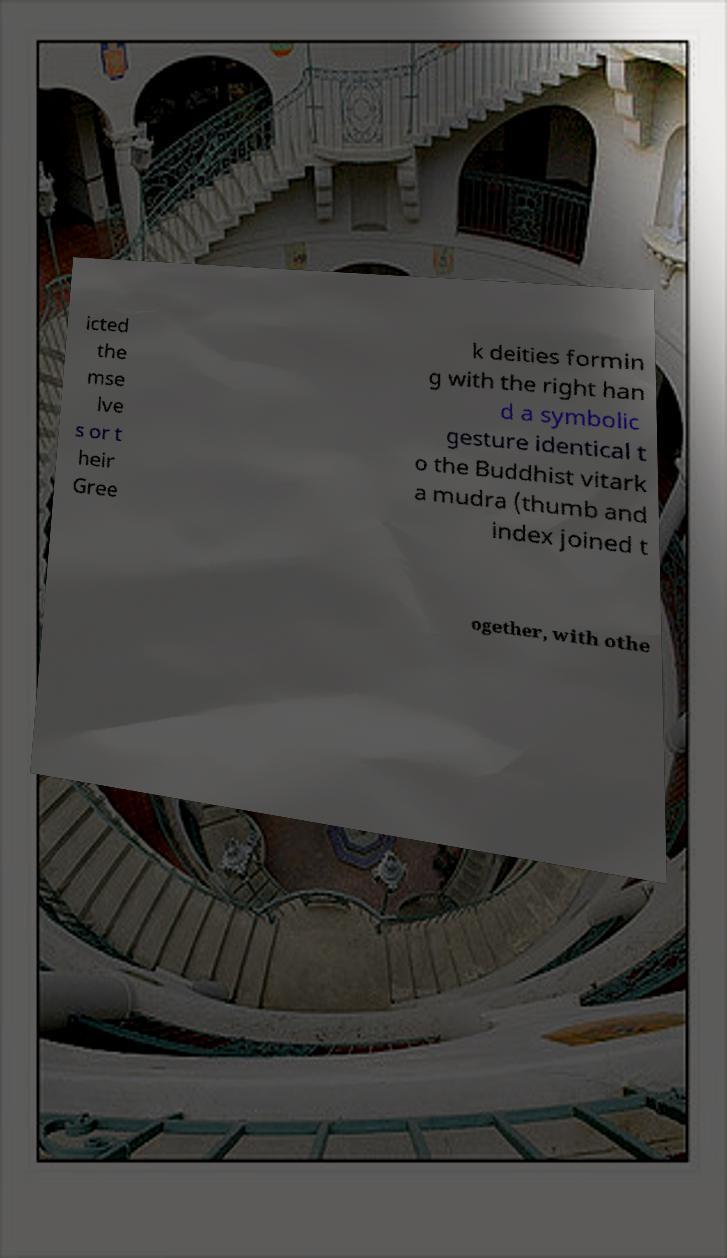Please identify and transcribe the text found in this image. icted the mse lve s or t heir Gree k deities formin g with the right han d a symbolic gesture identical t o the Buddhist vitark a mudra (thumb and index joined t ogether, with othe 